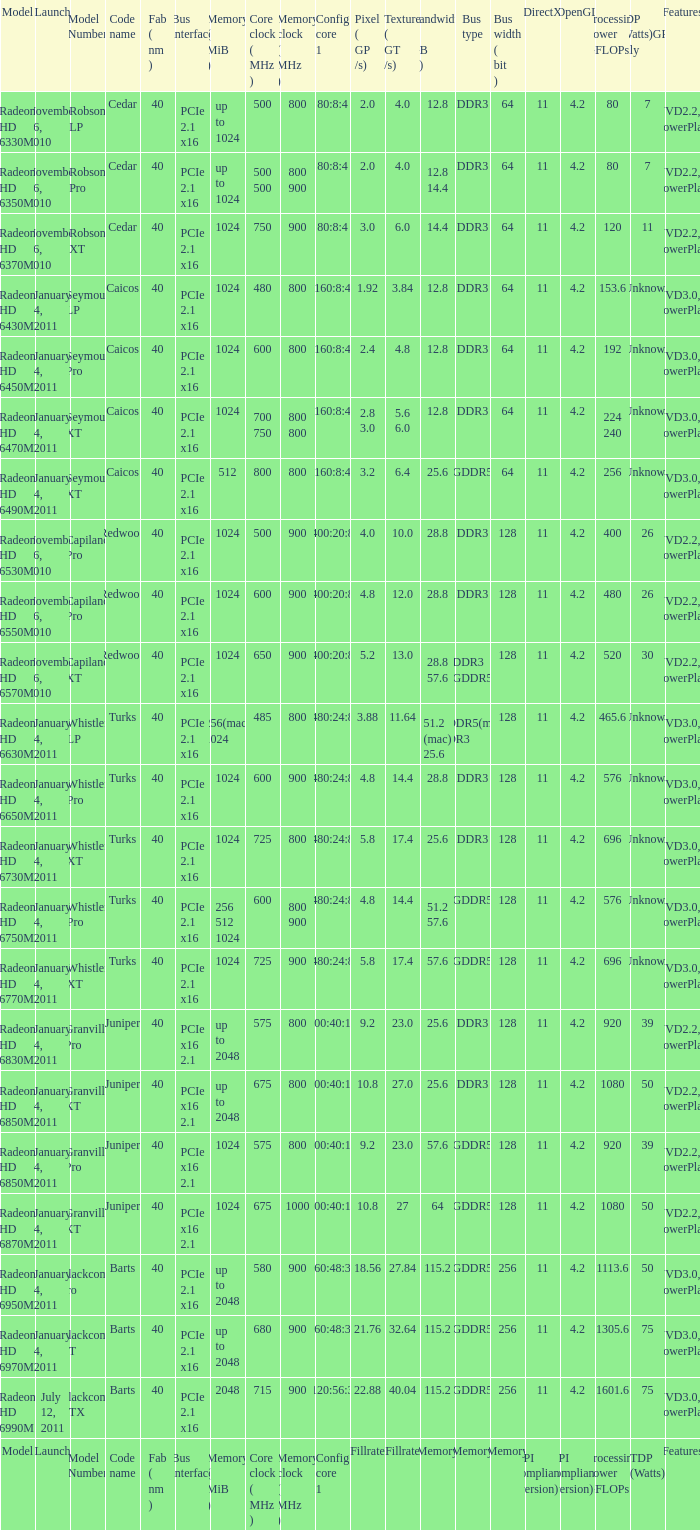What is every code name for the model Radeon HD 6650m? Turks. 